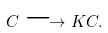Convert formula to latex. <formula><loc_0><loc_0><loc_500><loc_500>C \longrightarrow K C .</formula> 